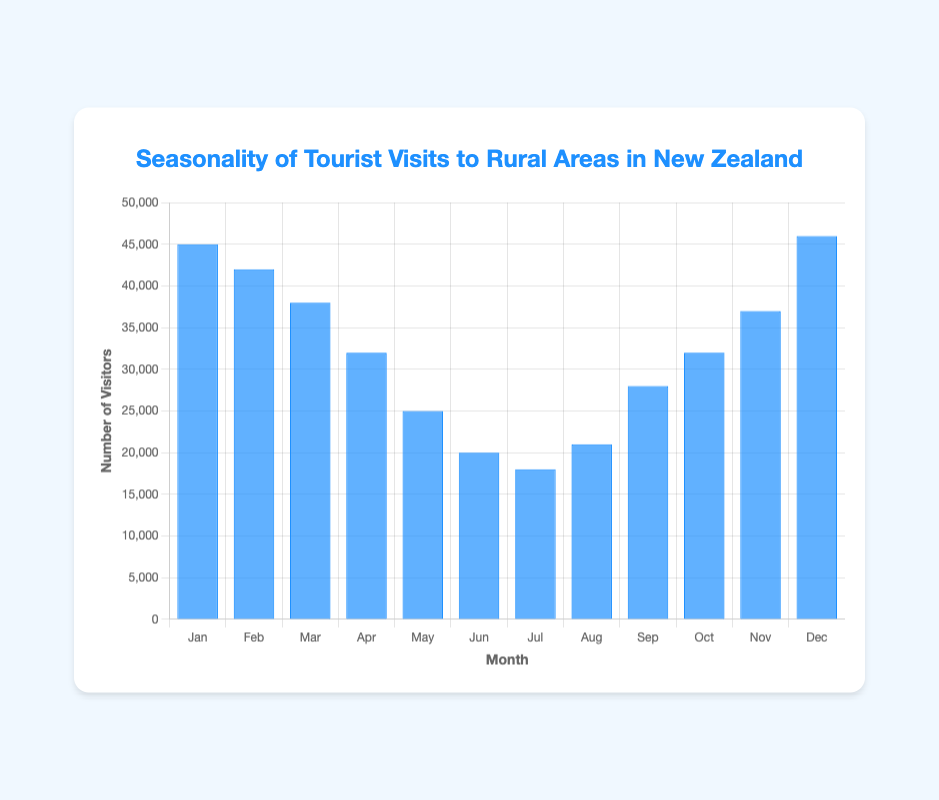Which month had the highest number of visitors? By checking the heights of the bars, the bar representing December extends the furthest, indicating the highest number of visitors at 46,000.
Answer: December What is the difference in the number of visitors between January and July? January had 45,000 visitors, and July had 18,000 visitors. Subtracting the two numbers: 45,000 - 18,000 = 27,000.
Answer: 27,000 In which month did tourist visits begin to exceed 30,000 after the winter low? Winter's low is in June and July, with the next notable increase in August, which lies below 30,000. Subsequently, September, with 28,000, still lies below 30,000. Finally, from October onward, the visits exceed 30,000 again.
Answer: October How many visitors were there on average over the summer months (December, January, February)? Summer months in New Zealand are December, January, and February. Adding the numbers: 46,000 (Dec) + 45,000 (Jan) + 42,000 (Feb) = 133,000, then average: 133,000 / 3 = 44,333.33.
Answer: 44,333.33 Which month had the least number of visitors? By checking the lengths of the bars, July is the shortest, indicating the lowest number of visitors at 18,000.
Answer: July Which month had the second highest number of visitors? After identifying December as the highest, January, with 45,000 visitors, stands as the second highest bar.
Answer: January 